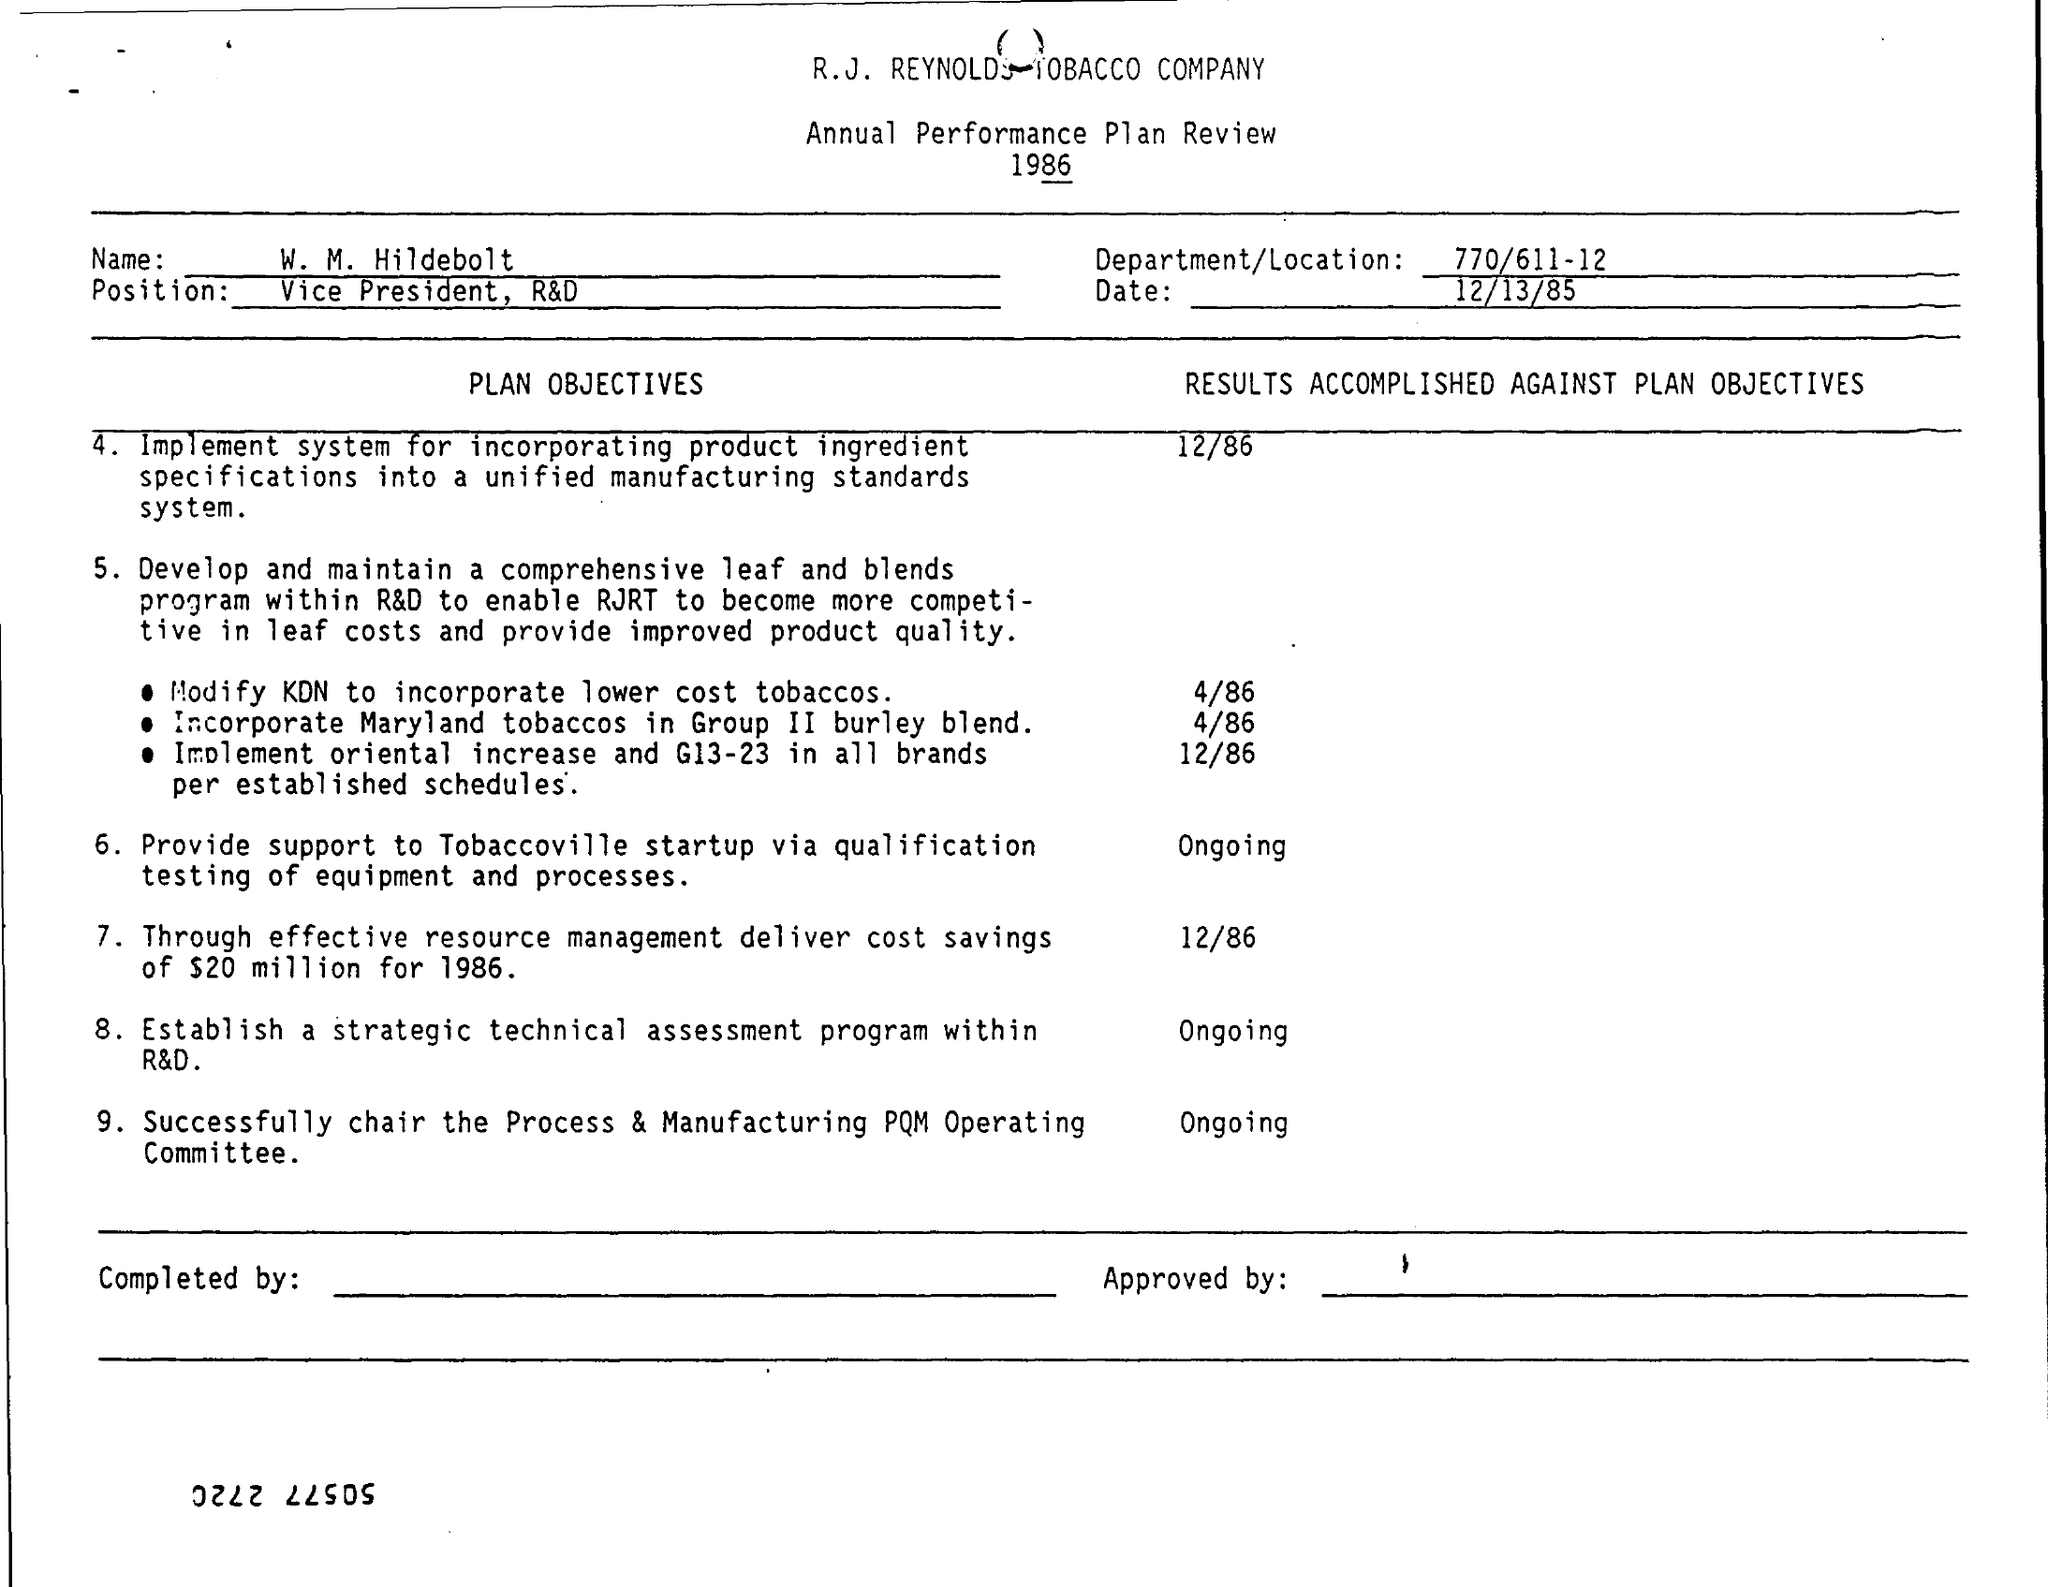Highlight a few significant elements in this photo. R.J. Reynolds Tobacco Company is the name of the company mentioned in the plan review. The results of the modification to KDN to reduce costs were accomplished on April 86. The date mentioned in the plan review is December 13, 1985. On the date that the results of the incorporation of Maryland tobacco in Group Burley Blend were accomplished, it was April 1986. We are currently in the process of establishing a strategic technical assessment program within our R&D department. This program aims to evaluate the results of our technical efforts on a specific date that has not yet been determined. 